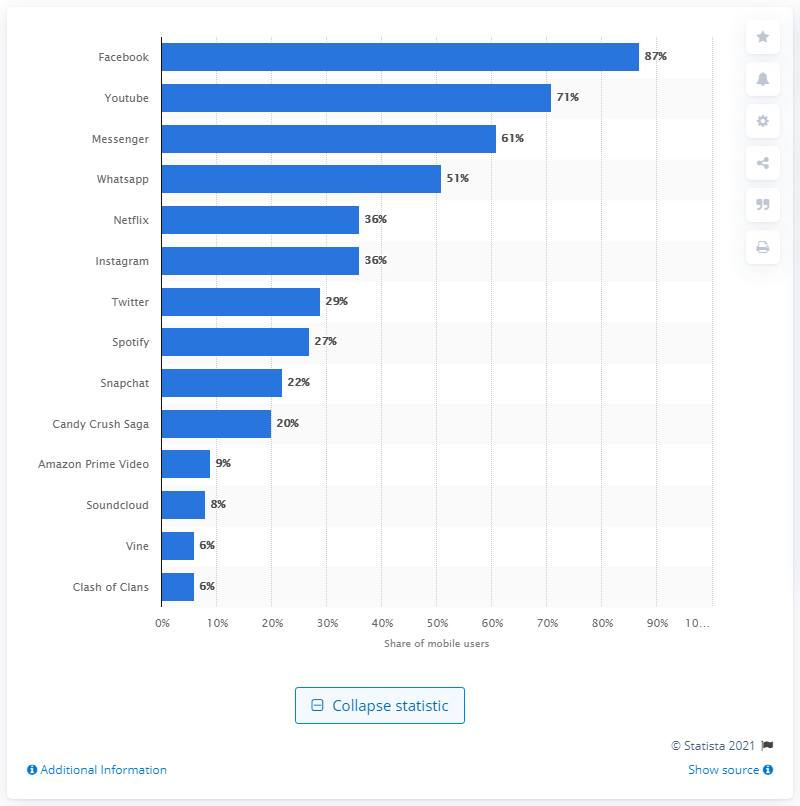Outline some significant characteristics in this image. According to the survey results, 22% of respondents reported using Snapchat at least once a week. 